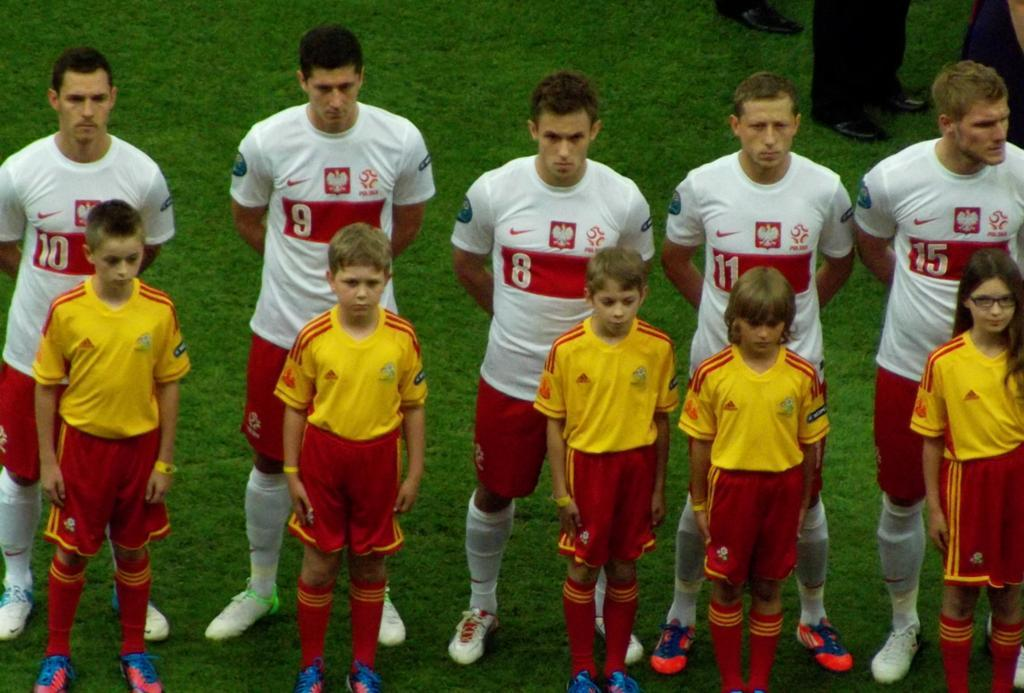How many people are in the image? There is a group of people in the image, but the exact number is not specified. What is the setting of the image? The people are standing on a grassy land. What type of basket is being used by the people in the image? There is no basket present in the image. What flavor of ice cream are the people enjoying in the image? There is no ice cream present in the image. 